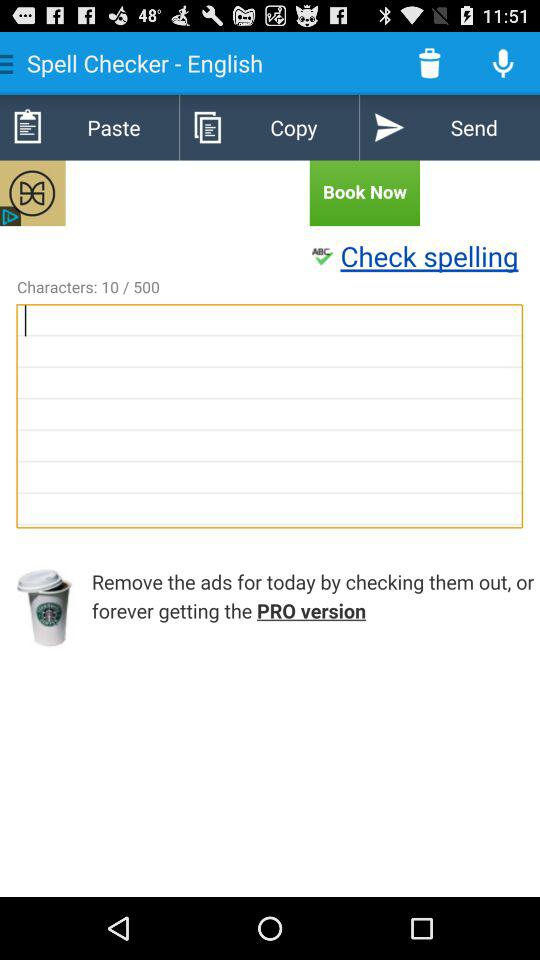What is the total number of characters to write in the textbox? The total number of characters to write in the textbox is 500. 